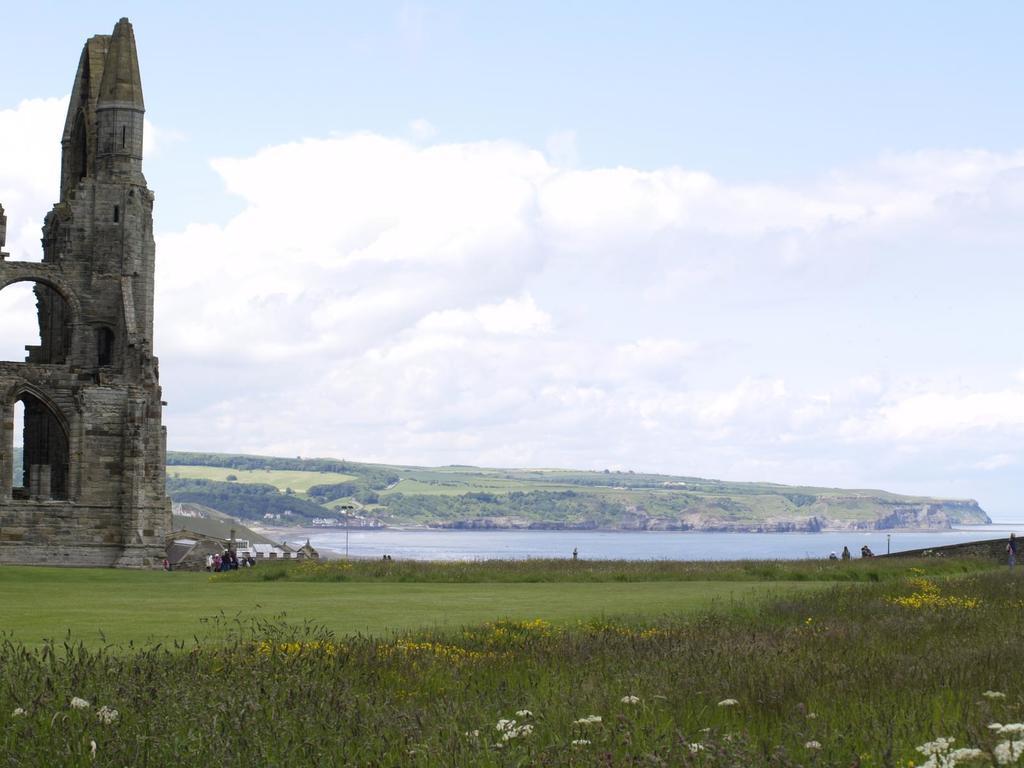In one or two sentences, can you explain what this image depicts? On the ground there is grass and plants. On the left side there is a building with arches and brick wall. In the back there is water and hill with trees. Also there is sky with clouds. 